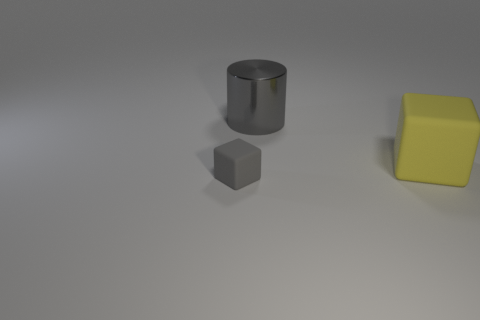What size is the metallic object that is the same color as the tiny matte block?
Offer a terse response. Large. How many other objects are the same size as the metal object?
Give a very brief answer. 1. What is the gray thing in front of the yellow thing made of?
Make the answer very short. Rubber. Do the tiny gray rubber thing and the big gray metal object have the same shape?
Your response must be concise. No. What number of other objects are there of the same shape as the shiny object?
Provide a succinct answer. 0. The matte block that is on the left side of the yellow matte thing is what color?
Provide a succinct answer. Gray. Does the gray cylinder have the same size as the yellow object?
Ensure brevity in your answer.  Yes. There is a block behind the gray object in front of the big cylinder; what is its material?
Give a very brief answer. Rubber. How many big metallic cylinders are the same color as the big metallic object?
Offer a very short reply. 0. Is there anything else that has the same material as the gray cube?
Make the answer very short. Yes. 